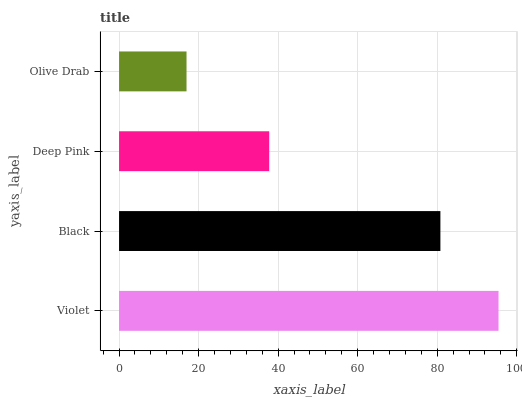Is Olive Drab the minimum?
Answer yes or no. Yes. Is Violet the maximum?
Answer yes or no. Yes. Is Black the minimum?
Answer yes or no. No. Is Black the maximum?
Answer yes or no. No. Is Violet greater than Black?
Answer yes or no. Yes. Is Black less than Violet?
Answer yes or no. Yes. Is Black greater than Violet?
Answer yes or no. No. Is Violet less than Black?
Answer yes or no. No. Is Black the high median?
Answer yes or no. Yes. Is Deep Pink the low median?
Answer yes or no. Yes. Is Olive Drab the high median?
Answer yes or no. No. Is Olive Drab the low median?
Answer yes or no. No. 